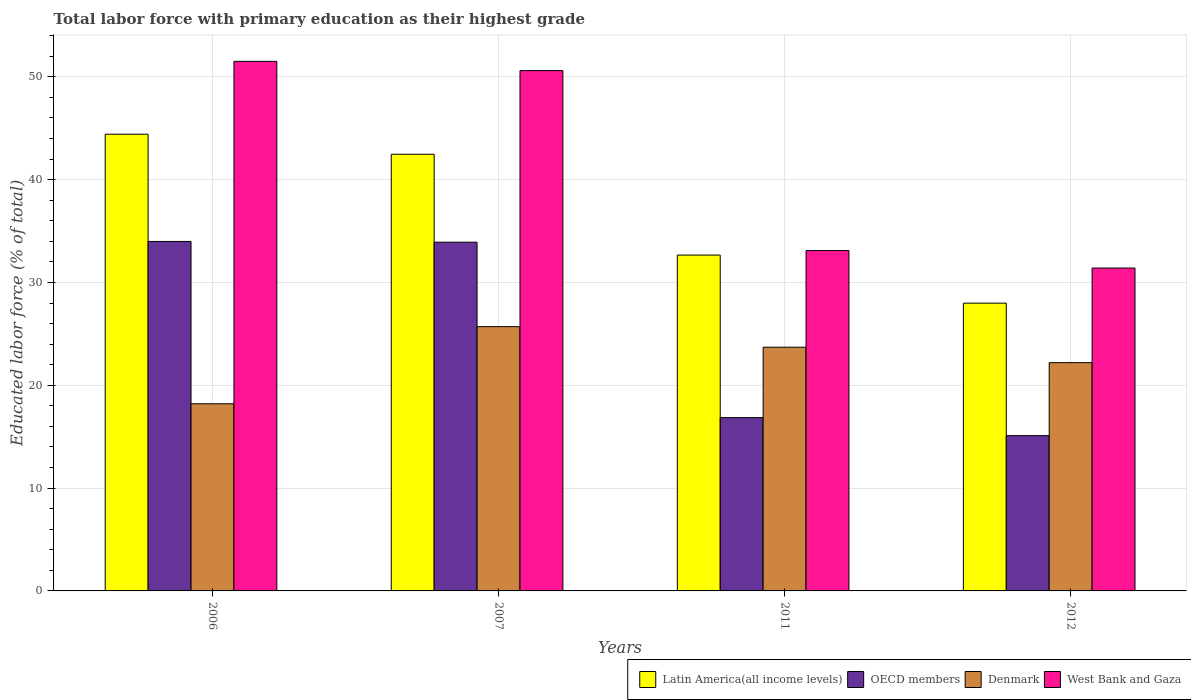How many different coloured bars are there?
Ensure brevity in your answer.  4. How many groups of bars are there?
Give a very brief answer. 4. What is the label of the 4th group of bars from the left?
Keep it short and to the point. 2012. In how many cases, is the number of bars for a given year not equal to the number of legend labels?
Offer a very short reply. 0. What is the percentage of total labor force with primary education in Latin America(all income levels) in 2011?
Your answer should be very brief. 32.66. Across all years, what is the maximum percentage of total labor force with primary education in Latin America(all income levels)?
Provide a succinct answer. 44.41. Across all years, what is the minimum percentage of total labor force with primary education in West Bank and Gaza?
Your answer should be compact. 31.4. In which year was the percentage of total labor force with primary education in OECD members maximum?
Offer a terse response. 2006. In which year was the percentage of total labor force with primary education in Denmark minimum?
Your answer should be compact. 2006. What is the total percentage of total labor force with primary education in OECD members in the graph?
Make the answer very short. 99.86. What is the difference between the percentage of total labor force with primary education in OECD members in 2007 and that in 2012?
Your response must be concise. 18.81. What is the difference between the percentage of total labor force with primary education in West Bank and Gaza in 2007 and the percentage of total labor force with primary education in Latin America(all income levels) in 2012?
Your answer should be very brief. 22.61. What is the average percentage of total labor force with primary education in Latin America(all income levels) per year?
Provide a short and direct response. 36.88. In the year 2012, what is the difference between the percentage of total labor force with primary education in Latin America(all income levels) and percentage of total labor force with primary education in OECD members?
Provide a succinct answer. 12.88. What is the ratio of the percentage of total labor force with primary education in Latin America(all income levels) in 2011 to that in 2012?
Ensure brevity in your answer.  1.17. Is the difference between the percentage of total labor force with primary education in Latin America(all income levels) in 2007 and 2012 greater than the difference between the percentage of total labor force with primary education in OECD members in 2007 and 2012?
Give a very brief answer. No. What is the difference between the highest and the second highest percentage of total labor force with primary education in OECD members?
Offer a terse response. 0.07. What is the difference between the highest and the lowest percentage of total labor force with primary education in OECD members?
Make the answer very short. 18.88. In how many years, is the percentage of total labor force with primary education in Denmark greater than the average percentage of total labor force with primary education in Denmark taken over all years?
Make the answer very short. 2. Is it the case that in every year, the sum of the percentage of total labor force with primary education in Latin America(all income levels) and percentage of total labor force with primary education in Denmark is greater than the sum of percentage of total labor force with primary education in OECD members and percentage of total labor force with primary education in West Bank and Gaza?
Make the answer very short. Yes. What does the 1st bar from the right in 2012 represents?
Keep it short and to the point. West Bank and Gaza. Is it the case that in every year, the sum of the percentage of total labor force with primary education in West Bank and Gaza and percentage of total labor force with primary education in Latin America(all income levels) is greater than the percentage of total labor force with primary education in Denmark?
Provide a succinct answer. Yes. How are the legend labels stacked?
Your answer should be very brief. Horizontal. What is the title of the graph?
Give a very brief answer. Total labor force with primary education as their highest grade. What is the label or title of the X-axis?
Your answer should be very brief. Years. What is the label or title of the Y-axis?
Your response must be concise. Educated labor force (% of total). What is the Educated labor force (% of total) in Latin America(all income levels) in 2006?
Offer a terse response. 44.41. What is the Educated labor force (% of total) in OECD members in 2006?
Make the answer very short. 33.99. What is the Educated labor force (% of total) of Denmark in 2006?
Provide a succinct answer. 18.2. What is the Educated labor force (% of total) in West Bank and Gaza in 2006?
Your answer should be very brief. 51.5. What is the Educated labor force (% of total) in Latin America(all income levels) in 2007?
Provide a short and direct response. 42.47. What is the Educated labor force (% of total) in OECD members in 2007?
Your answer should be compact. 33.91. What is the Educated labor force (% of total) in Denmark in 2007?
Ensure brevity in your answer.  25.7. What is the Educated labor force (% of total) in West Bank and Gaza in 2007?
Ensure brevity in your answer.  50.6. What is the Educated labor force (% of total) in Latin America(all income levels) in 2011?
Provide a succinct answer. 32.66. What is the Educated labor force (% of total) in OECD members in 2011?
Your answer should be very brief. 16.85. What is the Educated labor force (% of total) in Denmark in 2011?
Provide a succinct answer. 23.7. What is the Educated labor force (% of total) in West Bank and Gaza in 2011?
Offer a terse response. 33.1. What is the Educated labor force (% of total) of Latin America(all income levels) in 2012?
Your answer should be very brief. 27.99. What is the Educated labor force (% of total) in OECD members in 2012?
Ensure brevity in your answer.  15.1. What is the Educated labor force (% of total) of Denmark in 2012?
Make the answer very short. 22.2. What is the Educated labor force (% of total) of West Bank and Gaza in 2012?
Offer a terse response. 31.4. Across all years, what is the maximum Educated labor force (% of total) of Latin America(all income levels)?
Give a very brief answer. 44.41. Across all years, what is the maximum Educated labor force (% of total) of OECD members?
Ensure brevity in your answer.  33.99. Across all years, what is the maximum Educated labor force (% of total) in Denmark?
Give a very brief answer. 25.7. Across all years, what is the maximum Educated labor force (% of total) of West Bank and Gaza?
Keep it short and to the point. 51.5. Across all years, what is the minimum Educated labor force (% of total) of Latin America(all income levels)?
Provide a short and direct response. 27.99. Across all years, what is the minimum Educated labor force (% of total) in OECD members?
Offer a very short reply. 15.1. Across all years, what is the minimum Educated labor force (% of total) of Denmark?
Your answer should be very brief. 18.2. Across all years, what is the minimum Educated labor force (% of total) in West Bank and Gaza?
Ensure brevity in your answer.  31.4. What is the total Educated labor force (% of total) in Latin America(all income levels) in the graph?
Your response must be concise. 147.53. What is the total Educated labor force (% of total) of OECD members in the graph?
Provide a succinct answer. 99.86. What is the total Educated labor force (% of total) of Denmark in the graph?
Make the answer very short. 89.8. What is the total Educated labor force (% of total) of West Bank and Gaza in the graph?
Ensure brevity in your answer.  166.6. What is the difference between the Educated labor force (% of total) of Latin America(all income levels) in 2006 and that in 2007?
Your response must be concise. 1.95. What is the difference between the Educated labor force (% of total) of OECD members in 2006 and that in 2007?
Provide a succinct answer. 0.07. What is the difference between the Educated labor force (% of total) in Denmark in 2006 and that in 2007?
Your answer should be compact. -7.5. What is the difference between the Educated labor force (% of total) of Latin America(all income levels) in 2006 and that in 2011?
Keep it short and to the point. 11.75. What is the difference between the Educated labor force (% of total) of OECD members in 2006 and that in 2011?
Provide a succinct answer. 17.13. What is the difference between the Educated labor force (% of total) in Latin America(all income levels) in 2006 and that in 2012?
Give a very brief answer. 16.43. What is the difference between the Educated labor force (% of total) of OECD members in 2006 and that in 2012?
Ensure brevity in your answer.  18.88. What is the difference between the Educated labor force (% of total) in West Bank and Gaza in 2006 and that in 2012?
Your answer should be compact. 20.1. What is the difference between the Educated labor force (% of total) of Latin America(all income levels) in 2007 and that in 2011?
Keep it short and to the point. 9.8. What is the difference between the Educated labor force (% of total) of OECD members in 2007 and that in 2011?
Make the answer very short. 17.06. What is the difference between the Educated labor force (% of total) of Denmark in 2007 and that in 2011?
Offer a terse response. 2. What is the difference between the Educated labor force (% of total) of Latin America(all income levels) in 2007 and that in 2012?
Offer a terse response. 14.48. What is the difference between the Educated labor force (% of total) of OECD members in 2007 and that in 2012?
Make the answer very short. 18.81. What is the difference between the Educated labor force (% of total) in Denmark in 2007 and that in 2012?
Ensure brevity in your answer.  3.5. What is the difference between the Educated labor force (% of total) in West Bank and Gaza in 2007 and that in 2012?
Your answer should be compact. 19.2. What is the difference between the Educated labor force (% of total) of Latin America(all income levels) in 2011 and that in 2012?
Your answer should be compact. 4.68. What is the difference between the Educated labor force (% of total) in OECD members in 2011 and that in 2012?
Provide a succinct answer. 1.75. What is the difference between the Educated labor force (% of total) of Latin America(all income levels) in 2006 and the Educated labor force (% of total) of OECD members in 2007?
Keep it short and to the point. 10.5. What is the difference between the Educated labor force (% of total) of Latin America(all income levels) in 2006 and the Educated labor force (% of total) of Denmark in 2007?
Give a very brief answer. 18.71. What is the difference between the Educated labor force (% of total) of Latin America(all income levels) in 2006 and the Educated labor force (% of total) of West Bank and Gaza in 2007?
Your answer should be compact. -6.19. What is the difference between the Educated labor force (% of total) in OECD members in 2006 and the Educated labor force (% of total) in Denmark in 2007?
Keep it short and to the point. 8.29. What is the difference between the Educated labor force (% of total) of OECD members in 2006 and the Educated labor force (% of total) of West Bank and Gaza in 2007?
Your answer should be compact. -16.61. What is the difference between the Educated labor force (% of total) in Denmark in 2006 and the Educated labor force (% of total) in West Bank and Gaza in 2007?
Provide a succinct answer. -32.4. What is the difference between the Educated labor force (% of total) in Latin America(all income levels) in 2006 and the Educated labor force (% of total) in OECD members in 2011?
Offer a very short reply. 27.56. What is the difference between the Educated labor force (% of total) in Latin America(all income levels) in 2006 and the Educated labor force (% of total) in Denmark in 2011?
Your response must be concise. 20.71. What is the difference between the Educated labor force (% of total) of Latin America(all income levels) in 2006 and the Educated labor force (% of total) of West Bank and Gaza in 2011?
Your response must be concise. 11.31. What is the difference between the Educated labor force (% of total) in OECD members in 2006 and the Educated labor force (% of total) in Denmark in 2011?
Offer a terse response. 10.29. What is the difference between the Educated labor force (% of total) of OECD members in 2006 and the Educated labor force (% of total) of West Bank and Gaza in 2011?
Ensure brevity in your answer.  0.89. What is the difference between the Educated labor force (% of total) of Denmark in 2006 and the Educated labor force (% of total) of West Bank and Gaza in 2011?
Provide a succinct answer. -14.9. What is the difference between the Educated labor force (% of total) in Latin America(all income levels) in 2006 and the Educated labor force (% of total) in OECD members in 2012?
Ensure brevity in your answer.  29.31. What is the difference between the Educated labor force (% of total) in Latin America(all income levels) in 2006 and the Educated labor force (% of total) in Denmark in 2012?
Your response must be concise. 22.21. What is the difference between the Educated labor force (% of total) in Latin America(all income levels) in 2006 and the Educated labor force (% of total) in West Bank and Gaza in 2012?
Provide a short and direct response. 13.01. What is the difference between the Educated labor force (% of total) in OECD members in 2006 and the Educated labor force (% of total) in Denmark in 2012?
Ensure brevity in your answer.  11.79. What is the difference between the Educated labor force (% of total) of OECD members in 2006 and the Educated labor force (% of total) of West Bank and Gaza in 2012?
Offer a very short reply. 2.59. What is the difference between the Educated labor force (% of total) of Latin America(all income levels) in 2007 and the Educated labor force (% of total) of OECD members in 2011?
Offer a very short reply. 25.61. What is the difference between the Educated labor force (% of total) in Latin America(all income levels) in 2007 and the Educated labor force (% of total) in Denmark in 2011?
Provide a short and direct response. 18.77. What is the difference between the Educated labor force (% of total) of Latin America(all income levels) in 2007 and the Educated labor force (% of total) of West Bank and Gaza in 2011?
Ensure brevity in your answer.  9.37. What is the difference between the Educated labor force (% of total) of OECD members in 2007 and the Educated labor force (% of total) of Denmark in 2011?
Make the answer very short. 10.21. What is the difference between the Educated labor force (% of total) of OECD members in 2007 and the Educated labor force (% of total) of West Bank and Gaza in 2011?
Make the answer very short. 0.81. What is the difference between the Educated labor force (% of total) of Denmark in 2007 and the Educated labor force (% of total) of West Bank and Gaza in 2011?
Keep it short and to the point. -7.4. What is the difference between the Educated labor force (% of total) in Latin America(all income levels) in 2007 and the Educated labor force (% of total) in OECD members in 2012?
Your response must be concise. 27.36. What is the difference between the Educated labor force (% of total) in Latin America(all income levels) in 2007 and the Educated labor force (% of total) in Denmark in 2012?
Your answer should be compact. 20.27. What is the difference between the Educated labor force (% of total) of Latin America(all income levels) in 2007 and the Educated labor force (% of total) of West Bank and Gaza in 2012?
Offer a terse response. 11.07. What is the difference between the Educated labor force (% of total) in OECD members in 2007 and the Educated labor force (% of total) in Denmark in 2012?
Give a very brief answer. 11.71. What is the difference between the Educated labor force (% of total) of OECD members in 2007 and the Educated labor force (% of total) of West Bank and Gaza in 2012?
Make the answer very short. 2.51. What is the difference between the Educated labor force (% of total) of Denmark in 2007 and the Educated labor force (% of total) of West Bank and Gaza in 2012?
Provide a succinct answer. -5.7. What is the difference between the Educated labor force (% of total) in Latin America(all income levels) in 2011 and the Educated labor force (% of total) in OECD members in 2012?
Give a very brief answer. 17.56. What is the difference between the Educated labor force (% of total) in Latin America(all income levels) in 2011 and the Educated labor force (% of total) in Denmark in 2012?
Your answer should be very brief. 10.46. What is the difference between the Educated labor force (% of total) of Latin America(all income levels) in 2011 and the Educated labor force (% of total) of West Bank and Gaza in 2012?
Provide a short and direct response. 1.26. What is the difference between the Educated labor force (% of total) in OECD members in 2011 and the Educated labor force (% of total) in Denmark in 2012?
Give a very brief answer. -5.35. What is the difference between the Educated labor force (% of total) of OECD members in 2011 and the Educated labor force (% of total) of West Bank and Gaza in 2012?
Your answer should be very brief. -14.55. What is the average Educated labor force (% of total) of Latin America(all income levels) per year?
Your response must be concise. 36.88. What is the average Educated labor force (% of total) in OECD members per year?
Your response must be concise. 24.96. What is the average Educated labor force (% of total) of Denmark per year?
Provide a short and direct response. 22.45. What is the average Educated labor force (% of total) of West Bank and Gaza per year?
Ensure brevity in your answer.  41.65. In the year 2006, what is the difference between the Educated labor force (% of total) of Latin America(all income levels) and Educated labor force (% of total) of OECD members?
Your answer should be compact. 10.43. In the year 2006, what is the difference between the Educated labor force (% of total) in Latin America(all income levels) and Educated labor force (% of total) in Denmark?
Your answer should be very brief. 26.21. In the year 2006, what is the difference between the Educated labor force (% of total) of Latin America(all income levels) and Educated labor force (% of total) of West Bank and Gaza?
Keep it short and to the point. -7.09. In the year 2006, what is the difference between the Educated labor force (% of total) of OECD members and Educated labor force (% of total) of Denmark?
Give a very brief answer. 15.79. In the year 2006, what is the difference between the Educated labor force (% of total) in OECD members and Educated labor force (% of total) in West Bank and Gaza?
Provide a short and direct response. -17.51. In the year 2006, what is the difference between the Educated labor force (% of total) of Denmark and Educated labor force (% of total) of West Bank and Gaza?
Your answer should be very brief. -33.3. In the year 2007, what is the difference between the Educated labor force (% of total) in Latin America(all income levels) and Educated labor force (% of total) in OECD members?
Make the answer very short. 8.55. In the year 2007, what is the difference between the Educated labor force (% of total) in Latin America(all income levels) and Educated labor force (% of total) in Denmark?
Provide a succinct answer. 16.77. In the year 2007, what is the difference between the Educated labor force (% of total) in Latin America(all income levels) and Educated labor force (% of total) in West Bank and Gaza?
Offer a very short reply. -8.13. In the year 2007, what is the difference between the Educated labor force (% of total) of OECD members and Educated labor force (% of total) of Denmark?
Keep it short and to the point. 8.21. In the year 2007, what is the difference between the Educated labor force (% of total) in OECD members and Educated labor force (% of total) in West Bank and Gaza?
Give a very brief answer. -16.69. In the year 2007, what is the difference between the Educated labor force (% of total) in Denmark and Educated labor force (% of total) in West Bank and Gaza?
Make the answer very short. -24.9. In the year 2011, what is the difference between the Educated labor force (% of total) of Latin America(all income levels) and Educated labor force (% of total) of OECD members?
Your answer should be compact. 15.81. In the year 2011, what is the difference between the Educated labor force (% of total) of Latin America(all income levels) and Educated labor force (% of total) of Denmark?
Give a very brief answer. 8.96. In the year 2011, what is the difference between the Educated labor force (% of total) of Latin America(all income levels) and Educated labor force (% of total) of West Bank and Gaza?
Offer a very short reply. -0.44. In the year 2011, what is the difference between the Educated labor force (% of total) in OECD members and Educated labor force (% of total) in Denmark?
Offer a terse response. -6.85. In the year 2011, what is the difference between the Educated labor force (% of total) in OECD members and Educated labor force (% of total) in West Bank and Gaza?
Ensure brevity in your answer.  -16.25. In the year 2012, what is the difference between the Educated labor force (% of total) of Latin America(all income levels) and Educated labor force (% of total) of OECD members?
Your answer should be very brief. 12.88. In the year 2012, what is the difference between the Educated labor force (% of total) in Latin America(all income levels) and Educated labor force (% of total) in Denmark?
Give a very brief answer. 5.79. In the year 2012, what is the difference between the Educated labor force (% of total) in Latin America(all income levels) and Educated labor force (% of total) in West Bank and Gaza?
Provide a short and direct response. -3.41. In the year 2012, what is the difference between the Educated labor force (% of total) in OECD members and Educated labor force (% of total) in Denmark?
Give a very brief answer. -7.1. In the year 2012, what is the difference between the Educated labor force (% of total) in OECD members and Educated labor force (% of total) in West Bank and Gaza?
Keep it short and to the point. -16.3. In the year 2012, what is the difference between the Educated labor force (% of total) in Denmark and Educated labor force (% of total) in West Bank and Gaza?
Make the answer very short. -9.2. What is the ratio of the Educated labor force (% of total) of Latin America(all income levels) in 2006 to that in 2007?
Your answer should be compact. 1.05. What is the ratio of the Educated labor force (% of total) in Denmark in 2006 to that in 2007?
Offer a terse response. 0.71. What is the ratio of the Educated labor force (% of total) in West Bank and Gaza in 2006 to that in 2007?
Make the answer very short. 1.02. What is the ratio of the Educated labor force (% of total) in Latin America(all income levels) in 2006 to that in 2011?
Ensure brevity in your answer.  1.36. What is the ratio of the Educated labor force (% of total) of OECD members in 2006 to that in 2011?
Ensure brevity in your answer.  2.02. What is the ratio of the Educated labor force (% of total) of Denmark in 2006 to that in 2011?
Give a very brief answer. 0.77. What is the ratio of the Educated labor force (% of total) in West Bank and Gaza in 2006 to that in 2011?
Provide a succinct answer. 1.56. What is the ratio of the Educated labor force (% of total) in Latin America(all income levels) in 2006 to that in 2012?
Your answer should be compact. 1.59. What is the ratio of the Educated labor force (% of total) in OECD members in 2006 to that in 2012?
Ensure brevity in your answer.  2.25. What is the ratio of the Educated labor force (% of total) of Denmark in 2006 to that in 2012?
Ensure brevity in your answer.  0.82. What is the ratio of the Educated labor force (% of total) of West Bank and Gaza in 2006 to that in 2012?
Your answer should be compact. 1.64. What is the ratio of the Educated labor force (% of total) in Latin America(all income levels) in 2007 to that in 2011?
Ensure brevity in your answer.  1.3. What is the ratio of the Educated labor force (% of total) in OECD members in 2007 to that in 2011?
Ensure brevity in your answer.  2.01. What is the ratio of the Educated labor force (% of total) of Denmark in 2007 to that in 2011?
Keep it short and to the point. 1.08. What is the ratio of the Educated labor force (% of total) of West Bank and Gaza in 2007 to that in 2011?
Provide a short and direct response. 1.53. What is the ratio of the Educated labor force (% of total) of Latin America(all income levels) in 2007 to that in 2012?
Your answer should be very brief. 1.52. What is the ratio of the Educated labor force (% of total) in OECD members in 2007 to that in 2012?
Your response must be concise. 2.25. What is the ratio of the Educated labor force (% of total) in Denmark in 2007 to that in 2012?
Ensure brevity in your answer.  1.16. What is the ratio of the Educated labor force (% of total) in West Bank and Gaza in 2007 to that in 2012?
Offer a terse response. 1.61. What is the ratio of the Educated labor force (% of total) in Latin America(all income levels) in 2011 to that in 2012?
Give a very brief answer. 1.17. What is the ratio of the Educated labor force (% of total) of OECD members in 2011 to that in 2012?
Your answer should be very brief. 1.12. What is the ratio of the Educated labor force (% of total) in Denmark in 2011 to that in 2012?
Offer a very short reply. 1.07. What is the ratio of the Educated labor force (% of total) in West Bank and Gaza in 2011 to that in 2012?
Make the answer very short. 1.05. What is the difference between the highest and the second highest Educated labor force (% of total) in Latin America(all income levels)?
Keep it short and to the point. 1.95. What is the difference between the highest and the second highest Educated labor force (% of total) of OECD members?
Provide a short and direct response. 0.07. What is the difference between the highest and the lowest Educated labor force (% of total) in Latin America(all income levels)?
Provide a short and direct response. 16.43. What is the difference between the highest and the lowest Educated labor force (% of total) of OECD members?
Offer a very short reply. 18.88. What is the difference between the highest and the lowest Educated labor force (% of total) in West Bank and Gaza?
Provide a short and direct response. 20.1. 